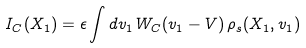<formula> <loc_0><loc_0><loc_500><loc_500>I _ { C } ( { X } _ { 1 } ) = \epsilon \int d v _ { 1 } \, W _ { C } ( v _ { 1 } - V ) \, \rho _ { s } ( { X } _ { 1 } , v _ { 1 } )</formula> 